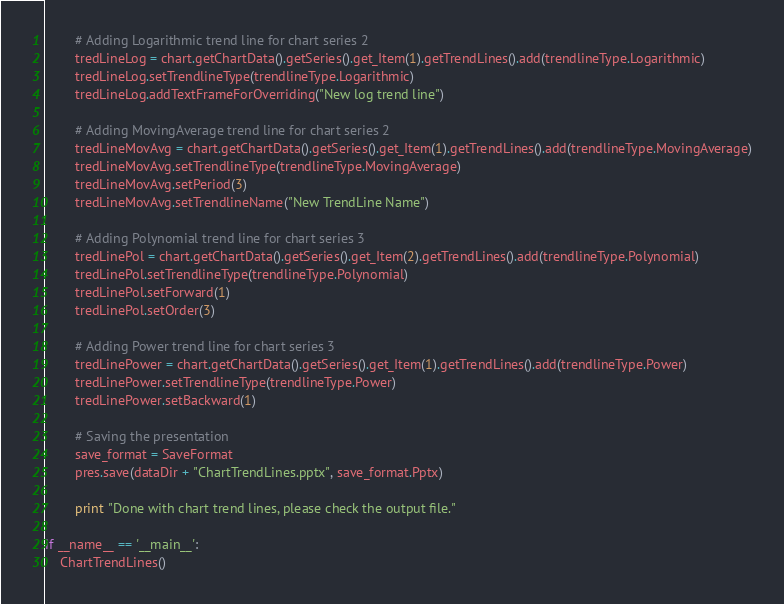<code> <loc_0><loc_0><loc_500><loc_500><_Python_>        # Adding Logarithmic trend line for chart series 2
        tredLineLog = chart.getChartData().getSeries().get_Item(1).getTrendLines().add(trendlineType.Logarithmic)
        tredLineLog.setTrendlineType(trendlineType.Logarithmic)
        tredLineLog.addTextFrameForOverriding("New log trend line")

        # Adding MovingAverage trend line for chart series 2
        tredLineMovAvg = chart.getChartData().getSeries().get_Item(1).getTrendLines().add(trendlineType.MovingAverage)
        tredLineMovAvg.setTrendlineType(trendlineType.MovingAverage)
        tredLineMovAvg.setPeriod(3)
        tredLineMovAvg.setTrendlineName("New TrendLine Name")

        # Adding Polynomial trend line for chart series 3
        tredLinePol = chart.getChartData().getSeries().get_Item(2).getTrendLines().add(trendlineType.Polynomial)
        tredLinePol.setTrendlineType(trendlineType.Polynomial)
        tredLinePol.setForward(1)
        tredLinePol.setOrder(3)

        # Adding Power trend line for chart series 3
        tredLinePower = chart.getChartData().getSeries().get_Item(1).getTrendLines().add(trendlineType.Power)
        tredLinePower.setTrendlineType(trendlineType.Power)
        tredLinePower.setBackward(1)

        # Saving the presentation
        save_format = SaveFormat
        pres.save(dataDir + "ChartTrendLines.pptx", save_format.Pptx)

        print "Done with chart trend lines, please check the output file."

if __name__ == '__main__':        
    ChartTrendLines()</code> 